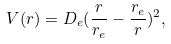<formula> <loc_0><loc_0><loc_500><loc_500>V ( r ) = D _ { e } ( \frac { r } { r _ { e } } - \frac { r _ { e } } { r } ) ^ { 2 } ,</formula> 